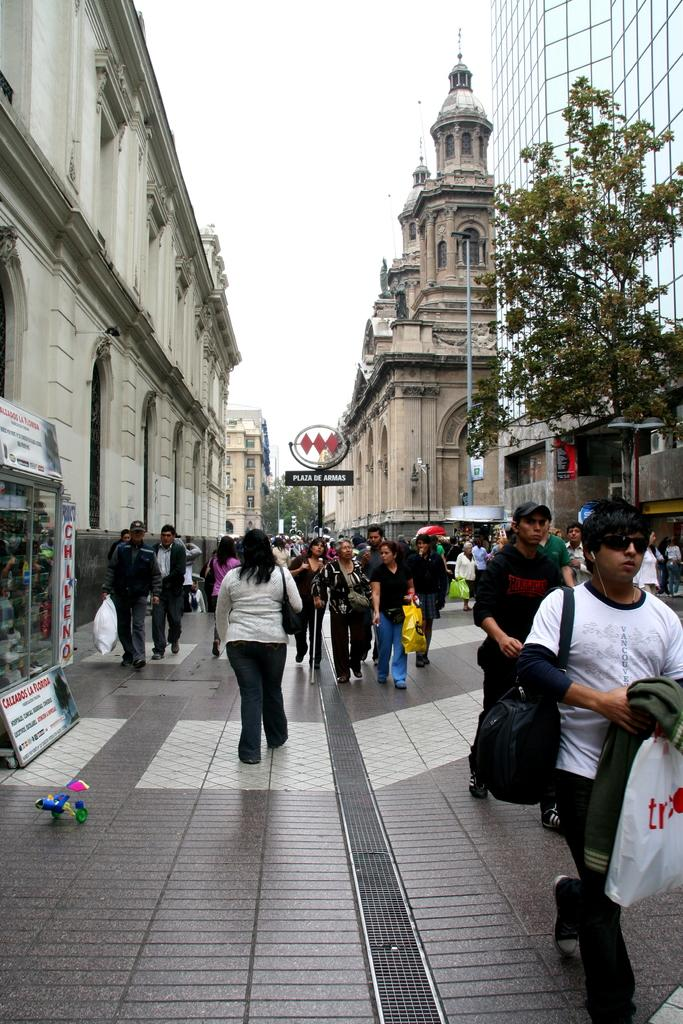What are the people in the image doing? The people in the image are walking. How is the floor in the image? The floor is paved. What can be seen in the background of the image? There are buildings and trees in the background of the image. What object is visible in the image? There is a pole visible in the image. What type of government is depicted in the image? There is no depiction of a government in the image; it features people walking, a paved floor, and buildings and trees in the background. Can you see a truck in the image? There is no truck present in the image. 